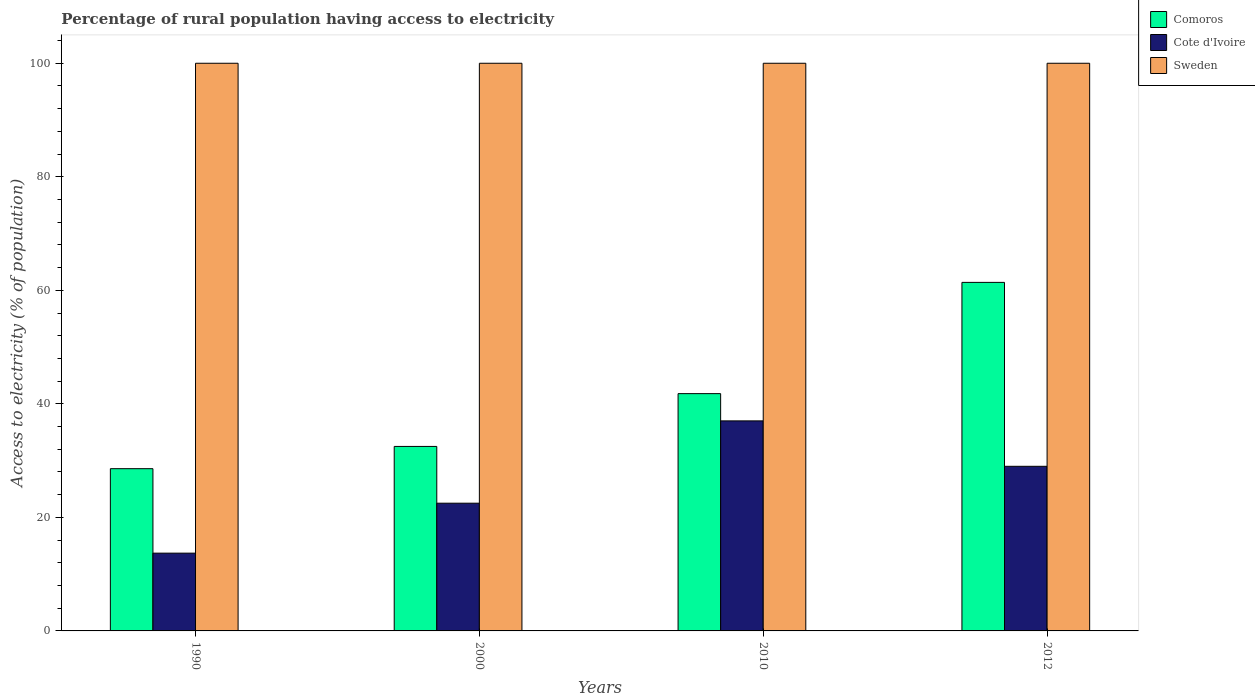How many different coloured bars are there?
Your response must be concise. 3. How many groups of bars are there?
Keep it short and to the point. 4. Are the number of bars on each tick of the X-axis equal?
Provide a short and direct response. Yes. How many bars are there on the 4th tick from the left?
Your answer should be very brief. 3. What is the label of the 2nd group of bars from the left?
Your answer should be very brief. 2000. What is the percentage of rural population having access to electricity in Cote d'Ivoire in 2000?
Your answer should be very brief. 22.5. Across all years, what is the maximum percentage of rural population having access to electricity in Sweden?
Offer a very short reply. 100. Across all years, what is the minimum percentage of rural population having access to electricity in Comoros?
Give a very brief answer. 28.58. What is the total percentage of rural population having access to electricity in Cote d'Ivoire in the graph?
Offer a very short reply. 102.2. What is the difference between the percentage of rural population having access to electricity in Cote d'Ivoire in 1990 and that in 2012?
Offer a very short reply. -15.3. What is the difference between the percentage of rural population having access to electricity in Sweden in 2000 and the percentage of rural population having access to electricity in Comoros in 1990?
Your answer should be very brief. 71.42. What is the average percentage of rural population having access to electricity in Comoros per year?
Provide a short and direct response. 41.07. In the year 1990, what is the difference between the percentage of rural population having access to electricity in Comoros and percentage of rural population having access to electricity in Cote d'Ivoire?
Your answer should be very brief. 14.88. In how many years, is the percentage of rural population having access to electricity in Comoros greater than 84 %?
Give a very brief answer. 0. What is the ratio of the percentage of rural population having access to electricity in Comoros in 2000 to that in 2010?
Offer a terse response. 0.78. Is the difference between the percentage of rural population having access to electricity in Comoros in 1990 and 2012 greater than the difference between the percentage of rural population having access to electricity in Cote d'Ivoire in 1990 and 2012?
Your answer should be very brief. No. What is the difference between the highest and the lowest percentage of rural population having access to electricity in Comoros?
Your answer should be compact. 32.82. What does the 1st bar from the left in 2012 represents?
Give a very brief answer. Comoros. What does the 3rd bar from the right in 2010 represents?
Ensure brevity in your answer.  Comoros. Is it the case that in every year, the sum of the percentage of rural population having access to electricity in Comoros and percentage of rural population having access to electricity in Cote d'Ivoire is greater than the percentage of rural population having access to electricity in Sweden?
Provide a succinct answer. No. How many years are there in the graph?
Keep it short and to the point. 4. What is the difference between two consecutive major ticks on the Y-axis?
Your answer should be very brief. 20. Are the values on the major ticks of Y-axis written in scientific E-notation?
Provide a succinct answer. No. Does the graph contain grids?
Provide a short and direct response. No. How many legend labels are there?
Your answer should be very brief. 3. What is the title of the graph?
Provide a short and direct response. Percentage of rural population having access to electricity. Does "Hong Kong" appear as one of the legend labels in the graph?
Offer a very short reply. No. What is the label or title of the X-axis?
Ensure brevity in your answer.  Years. What is the label or title of the Y-axis?
Keep it short and to the point. Access to electricity (% of population). What is the Access to electricity (% of population) of Comoros in 1990?
Offer a very short reply. 28.58. What is the Access to electricity (% of population) of Cote d'Ivoire in 1990?
Your answer should be compact. 13.7. What is the Access to electricity (% of population) of Comoros in 2000?
Ensure brevity in your answer.  32.5. What is the Access to electricity (% of population) in Sweden in 2000?
Your response must be concise. 100. What is the Access to electricity (% of population) of Comoros in 2010?
Make the answer very short. 41.8. What is the Access to electricity (% of population) of Cote d'Ivoire in 2010?
Your answer should be very brief. 37. What is the Access to electricity (% of population) of Comoros in 2012?
Offer a very short reply. 61.4. Across all years, what is the maximum Access to electricity (% of population) of Comoros?
Make the answer very short. 61.4. Across all years, what is the maximum Access to electricity (% of population) in Cote d'Ivoire?
Your response must be concise. 37. Across all years, what is the maximum Access to electricity (% of population) of Sweden?
Give a very brief answer. 100. Across all years, what is the minimum Access to electricity (% of population) in Comoros?
Provide a succinct answer. 28.58. Across all years, what is the minimum Access to electricity (% of population) in Cote d'Ivoire?
Provide a short and direct response. 13.7. Across all years, what is the minimum Access to electricity (% of population) of Sweden?
Your answer should be very brief. 100. What is the total Access to electricity (% of population) of Comoros in the graph?
Give a very brief answer. 164.28. What is the total Access to electricity (% of population) of Cote d'Ivoire in the graph?
Your answer should be very brief. 102.2. What is the difference between the Access to electricity (% of population) in Comoros in 1990 and that in 2000?
Your answer should be very brief. -3.92. What is the difference between the Access to electricity (% of population) in Comoros in 1990 and that in 2010?
Provide a succinct answer. -13.22. What is the difference between the Access to electricity (% of population) in Cote d'Ivoire in 1990 and that in 2010?
Ensure brevity in your answer.  -23.3. What is the difference between the Access to electricity (% of population) in Sweden in 1990 and that in 2010?
Keep it short and to the point. 0. What is the difference between the Access to electricity (% of population) in Comoros in 1990 and that in 2012?
Give a very brief answer. -32.82. What is the difference between the Access to electricity (% of population) in Cote d'Ivoire in 1990 and that in 2012?
Offer a terse response. -15.3. What is the difference between the Access to electricity (% of population) in Sweden in 1990 and that in 2012?
Provide a short and direct response. 0. What is the difference between the Access to electricity (% of population) of Comoros in 2000 and that in 2010?
Your response must be concise. -9.3. What is the difference between the Access to electricity (% of population) of Cote d'Ivoire in 2000 and that in 2010?
Provide a succinct answer. -14.5. What is the difference between the Access to electricity (% of population) in Comoros in 2000 and that in 2012?
Offer a very short reply. -28.9. What is the difference between the Access to electricity (% of population) in Cote d'Ivoire in 2000 and that in 2012?
Give a very brief answer. -6.5. What is the difference between the Access to electricity (% of population) in Comoros in 2010 and that in 2012?
Your answer should be compact. -19.6. What is the difference between the Access to electricity (% of population) of Sweden in 2010 and that in 2012?
Provide a succinct answer. 0. What is the difference between the Access to electricity (% of population) in Comoros in 1990 and the Access to electricity (% of population) in Cote d'Ivoire in 2000?
Offer a very short reply. 6.08. What is the difference between the Access to electricity (% of population) in Comoros in 1990 and the Access to electricity (% of population) in Sweden in 2000?
Offer a terse response. -71.42. What is the difference between the Access to electricity (% of population) of Cote d'Ivoire in 1990 and the Access to electricity (% of population) of Sweden in 2000?
Your answer should be very brief. -86.3. What is the difference between the Access to electricity (% of population) in Comoros in 1990 and the Access to electricity (% of population) in Cote d'Ivoire in 2010?
Your response must be concise. -8.42. What is the difference between the Access to electricity (% of population) of Comoros in 1990 and the Access to electricity (% of population) of Sweden in 2010?
Give a very brief answer. -71.42. What is the difference between the Access to electricity (% of population) in Cote d'Ivoire in 1990 and the Access to electricity (% of population) in Sweden in 2010?
Your answer should be compact. -86.3. What is the difference between the Access to electricity (% of population) in Comoros in 1990 and the Access to electricity (% of population) in Cote d'Ivoire in 2012?
Offer a terse response. -0.42. What is the difference between the Access to electricity (% of population) in Comoros in 1990 and the Access to electricity (% of population) in Sweden in 2012?
Give a very brief answer. -71.42. What is the difference between the Access to electricity (% of population) of Cote d'Ivoire in 1990 and the Access to electricity (% of population) of Sweden in 2012?
Ensure brevity in your answer.  -86.3. What is the difference between the Access to electricity (% of population) of Comoros in 2000 and the Access to electricity (% of population) of Cote d'Ivoire in 2010?
Make the answer very short. -4.5. What is the difference between the Access to electricity (% of population) of Comoros in 2000 and the Access to electricity (% of population) of Sweden in 2010?
Your answer should be very brief. -67.5. What is the difference between the Access to electricity (% of population) of Cote d'Ivoire in 2000 and the Access to electricity (% of population) of Sweden in 2010?
Ensure brevity in your answer.  -77.5. What is the difference between the Access to electricity (% of population) in Comoros in 2000 and the Access to electricity (% of population) in Sweden in 2012?
Give a very brief answer. -67.5. What is the difference between the Access to electricity (% of population) in Cote d'Ivoire in 2000 and the Access to electricity (% of population) in Sweden in 2012?
Give a very brief answer. -77.5. What is the difference between the Access to electricity (% of population) in Comoros in 2010 and the Access to electricity (% of population) in Cote d'Ivoire in 2012?
Offer a terse response. 12.8. What is the difference between the Access to electricity (% of population) of Comoros in 2010 and the Access to electricity (% of population) of Sweden in 2012?
Ensure brevity in your answer.  -58.2. What is the difference between the Access to electricity (% of population) in Cote d'Ivoire in 2010 and the Access to electricity (% of population) in Sweden in 2012?
Provide a succinct answer. -63. What is the average Access to electricity (% of population) of Comoros per year?
Offer a terse response. 41.07. What is the average Access to electricity (% of population) in Cote d'Ivoire per year?
Offer a terse response. 25.55. What is the average Access to electricity (% of population) in Sweden per year?
Ensure brevity in your answer.  100. In the year 1990, what is the difference between the Access to electricity (% of population) in Comoros and Access to electricity (% of population) in Cote d'Ivoire?
Give a very brief answer. 14.88. In the year 1990, what is the difference between the Access to electricity (% of population) in Comoros and Access to electricity (% of population) in Sweden?
Offer a very short reply. -71.42. In the year 1990, what is the difference between the Access to electricity (% of population) of Cote d'Ivoire and Access to electricity (% of population) of Sweden?
Your answer should be compact. -86.3. In the year 2000, what is the difference between the Access to electricity (% of population) of Comoros and Access to electricity (% of population) of Sweden?
Offer a terse response. -67.5. In the year 2000, what is the difference between the Access to electricity (% of population) in Cote d'Ivoire and Access to electricity (% of population) in Sweden?
Provide a succinct answer. -77.5. In the year 2010, what is the difference between the Access to electricity (% of population) of Comoros and Access to electricity (% of population) of Sweden?
Your answer should be compact. -58.2. In the year 2010, what is the difference between the Access to electricity (% of population) of Cote d'Ivoire and Access to electricity (% of population) of Sweden?
Keep it short and to the point. -63. In the year 2012, what is the difference between the Access to electricity (% of population) in Comoros and Access to electricity (% of population) in Cote d'Ivoire?
Provide a short and direct response. 32.4. In the year 2012, what is the difference between the Access to electricity (% of population) of Comoros and Access to electricity (% of population) of Sweden?
Offer a very short reply. -38.6. In the year 2012, what is the difference between the Access to electricity (% of population) in Cote d'Ivoire and Access to electricity (% of population) in Sweden?
Keep it short and to the point. -71. What is the ratio of the Access to electricity (% of population) in Comoros in 1990 to that in 2000?
Provide a short and direct response. 0.88. What is the ratio of the Access to electricity (% of population) in Cote d'Ivoire in 1990 to that in 2000?
Offer a very short reply. 0.61. What is the ratio of the Access to electricity (% of population) of Sweden in 1990 to that in 2000?
Offer a very short reply. 1. What is the ratio of the Access to electricity (% of population) in Comoros in 1990 to that in 2010?
Provide a succinct answer. 0.68. What is the ratio of the Access to electricity (% of population) of Cote d'Ivoire in 1990 to that in 2010?
Keep it short and to the point. 0.37. What is the ratio of the Access to electricity (% of population) of Sweden in 1990 to that in 2010?
Offer a very short reply. 1. What is the ratio of the Access to electricity (% of population) of Comoros in 1990 to that in 2012?
Ensure brevity in your answer.  0.47. What is the ratio of the Access to electricity (% of population) of Cote d'Ivoire in 1990 to that in 2012?
Your response must be concise. 0.47. What is the ratio of the Access to electricity (% of population) in Sweden in 1990 to that in 2012?
Your answer should be compact. 1. What is the ratio of the Access to electricity (% of population) of Comoros in 2000 to that in 2010?
Your answer should be compact. 0.78. What is the ratio of the Access to electricity (% of population) in Cote d'Ivoire in 2000 to that in 2010?
Offer a terse response. 0.61. What is the ratio of the Access to electricity (% of population) of Comoros in 2000 to that in 2012?
Provide a succinct answer. 0.53. What is the ratio of the Access to electricity (% of population) of Cote d'Ivoire in 2000 to that in 2012?
Keep it short and to the point. 0.78. What is the ratio of the Access to electricity (% of population) of Comoros in 2010 to that in 2012?
Provide a short and direct response. 0.68. What is the ratio of the Access to electricity (% of population) of Cote d'Ivoire in 2010 to that in 2012?
Give a very brief answer. 1.28. What is the difference between the highest and the second highest Access to electricity (% of population) in Comoros?
Make the answer very short. 19.6. What is the difference between the highest and the lowest Access to electricity (% of population) in Comoros?
Provide a succinct answer. 32.82. What is the difference between the highest and the lowest Access to electricity (% of population) of Cote d'Ivoire?
Provide a succinct answer. 23.3. 